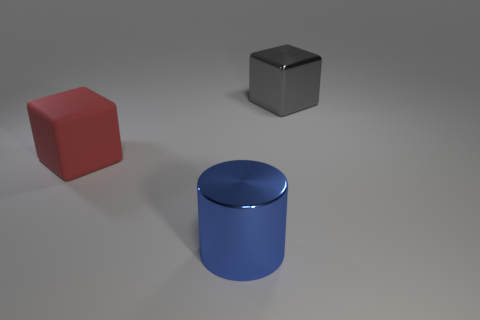Subtract all gray blocks. Subtract all yellow spheres. How many blocks are left? 1 Add 1 big shiny things. How many objects exist? 4 Subtract all cylinders. How many objects are left? 2 Subtract 1 blue cylinders. How many objects are left? 2 Subtract all big purple metal cylinders. Subtract all large gray objects. How many objects are left? 2 Add 1 rubber objects. How many rubber objects are left? 2 Add 3 small spheres. How many small spheres exist? 3 